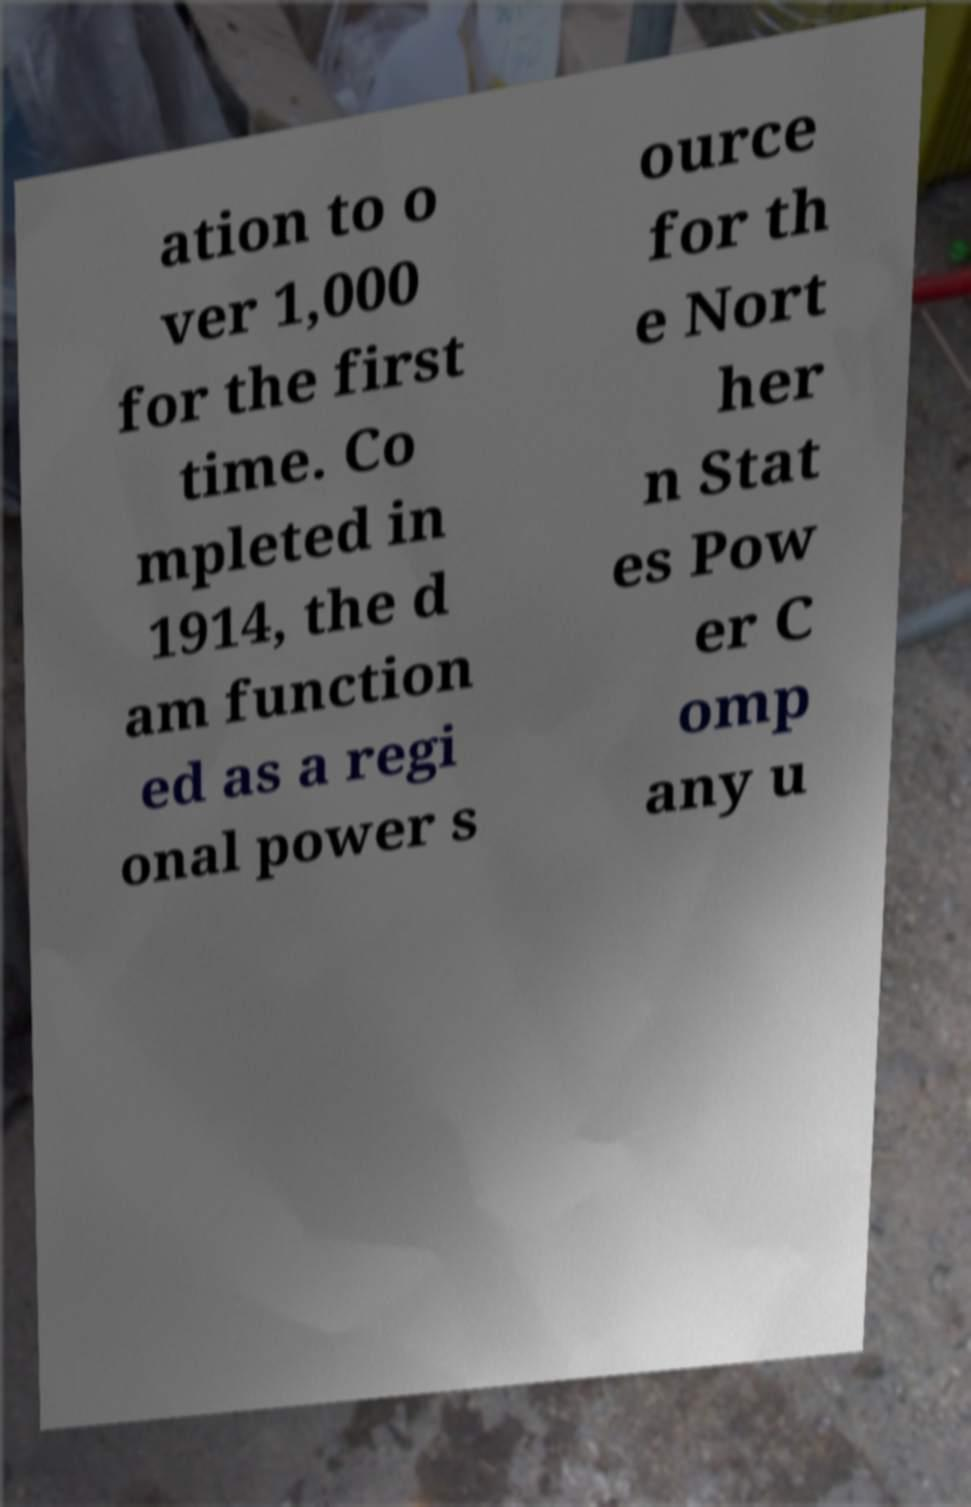There's text embedded in this image that I need extracted. Can you transcribe it verbatim? ation to o ver 1,000 for the first time. Co mpleted in 1914, the d am function ed as a regi onal power s ource for th e Nort her n Stat es Pow er C omp any u 